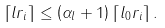Convert formula to latex. <formula><loc_0><loc_0><loc_500><loc_500>\left \lceil l r _ { i } \right \rceil \leq \left ( \alpha _ { l } + 1 \right ) \left \lceil l _ { 0 } r _ { i } \right \rceil .</formula> 